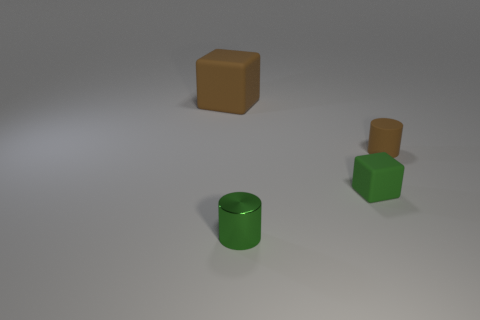Are there any other things that are the same size as the brown matte block?
Your answer should be compact. No. Is the block that is in front of the large brown block made of the same material as the small brown object?
Offer a very short reply. Yes. Is the number of large red metallic spheres less than the number of large brown rubber objects?
Your answer should be very brief. Yes. There is a green shiny cylinder in front of the small rubber thing to the right of the tiny cube; is there a matte thing right of it?
Ensure brevity in your answer.  Yes. Does the brown rubber object that is right of the brown matte cube have the same shape as the metal object?
Ensure brevity in your answer.  Yes. Are there more small cubes that are on the right side of the green cylinder than large red metallic cylinders?
Ensure brevity in your answer.  Yes. Do the block that is to the right of the large cube and the tiny metal cylinder have the same color?
Your answer should be very brief. Yes. Are there any other things that are the same color as the tiny matte cylinder?
Make the answer very short. Yes. There is a block that is in front of the tiny brown matte cylinder that is to the right of the brown rubber object that is on the left side of the tiny brown rubber thing; what color is it?
Your answer should be compact. Green. Is the size of the metallic cylinder the same as the brown cube?
Your answer should be compact. No. 